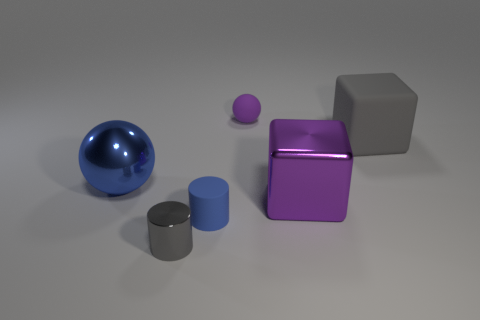Add 2 small metal cylinders. How many objects exist? 8 Subtract all cylinders. How many objects are left? 4 Add 6 gray matte objects. How many gray matte objects are left? 7 Add 3 small gray cylinders. How many small gray cylinders exist? 4 Subtract 0 red cylinders. How many objects are left? 6 Subtract all rubber balls. Subtract all purple metallic blocks. How many objects are left? 4 